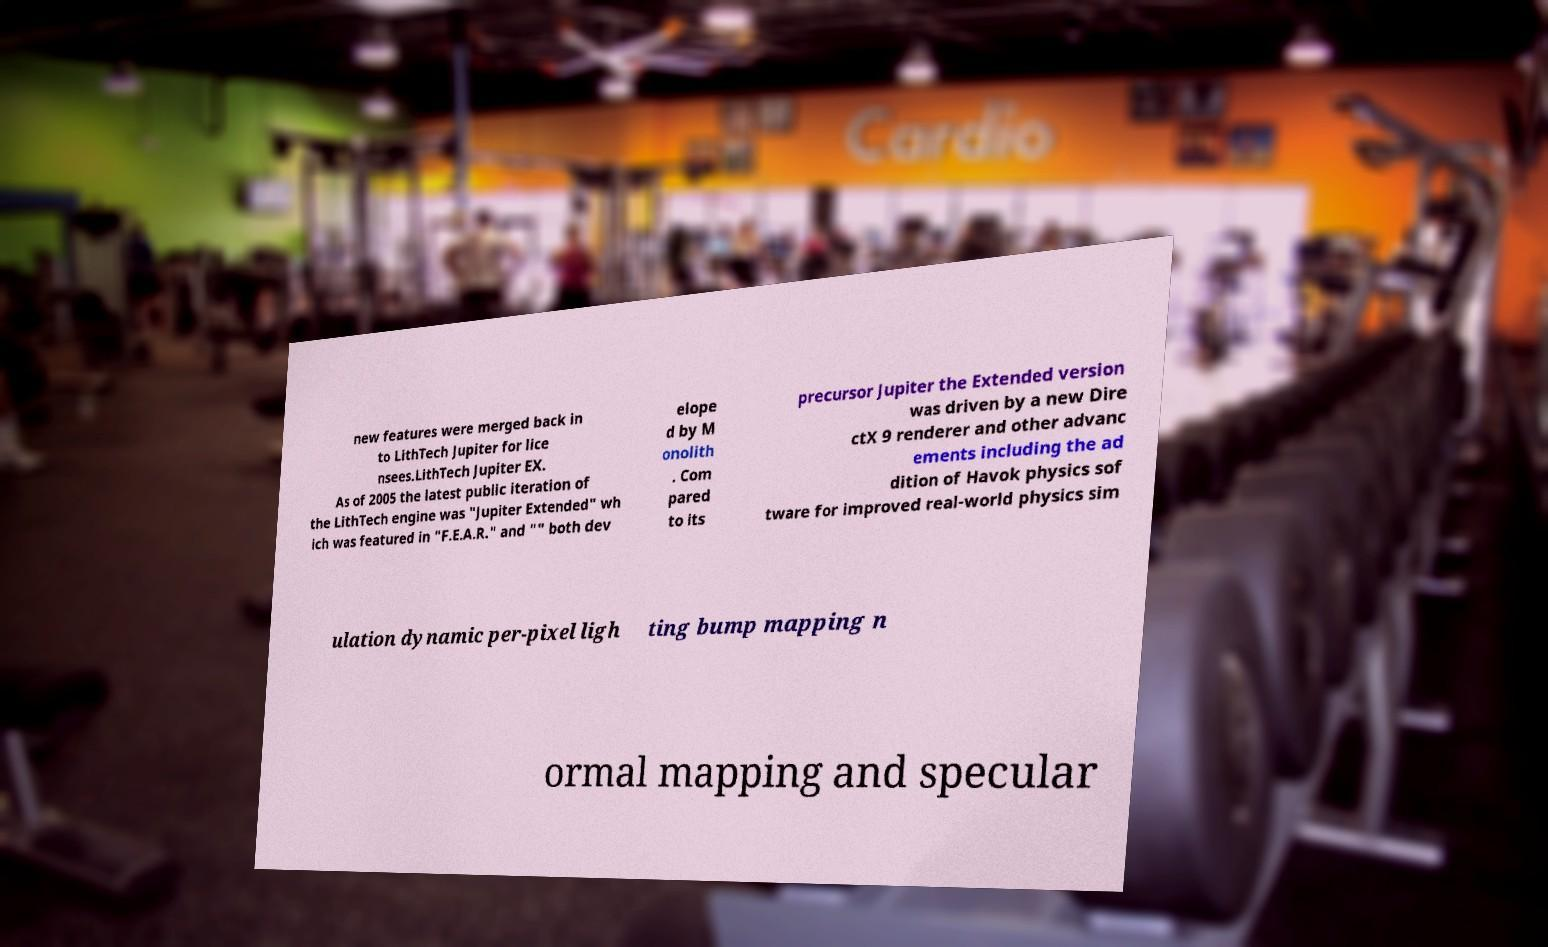Please read and relay the text visible in this image. What does it say? new features were merged back in to LithTech Jupiter for lice nsees.LithTech Jupiter EX. As of 2005 the latest public iteration of the LithTech engine was "Jupiter Extended" wh ich was featured in "F.E.A.R." and "" both dev elope d by M onolith . Com pared to its precursor Jupiter the Extended version was driven by a new Dire ctX 9 renderer and other advanc ements including the ad dition of Havok physics sof tware for improved real-world physics sim ulation dynamic per-pixel ligh ting bump mapping n ormal mapping and specular 